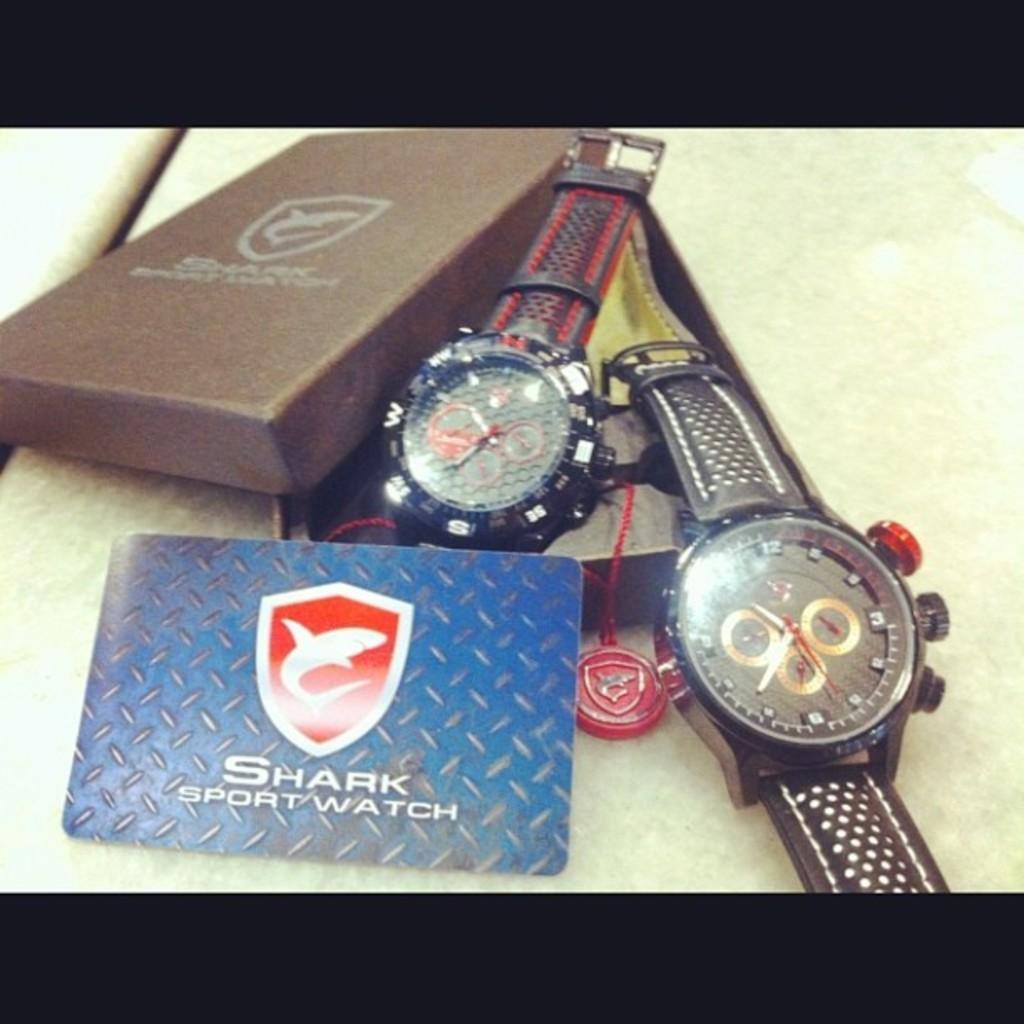<image>
Summarize the visual content of the image. Two Shark sport watches are next to each other. 